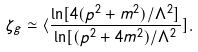Convert formula to latex. <formula><loc_0><loc_0><loc_500><loc_500>\zeta _ { g } \simeq \langle \frac { \ln [ 4 ( p ^ { 2 } + m ^ { 2 } ) / \Lambda ^ { 2 } ] } { \ln [ ( p ^ { 2 } + 4 m ^ { 2 } ) / \Lambda ^ { 2 } } ] .</formula> 